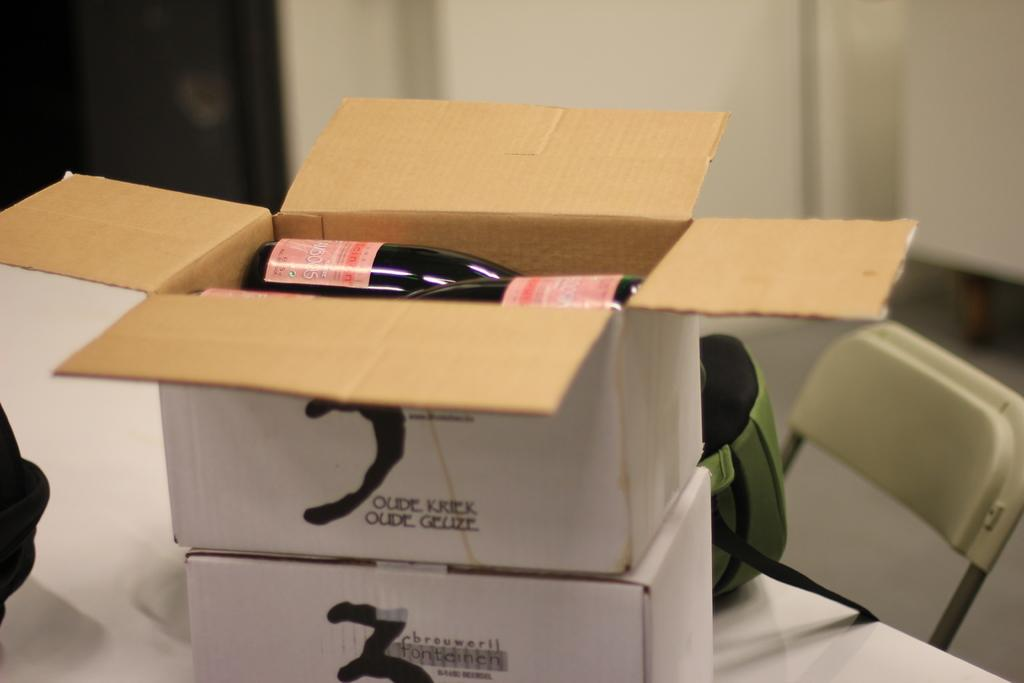Provide a one-sentence caption for the provided image. Two white boxes with the words Oude Kriek Oude Geuze on top of one another. 